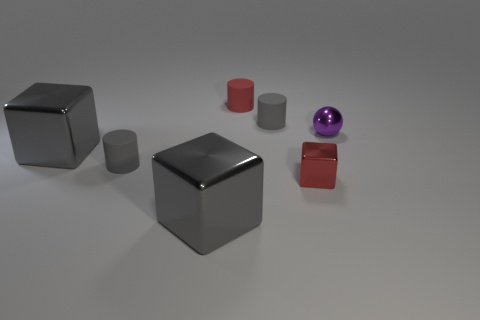Add 2 gray metallic things. How many objects exist? 9 Subtract all balls. How many objects are left? 6 Add 7 purple metal spheres. How many purple metal spheres are left? 8 Add 1 large gray objects. How many large gray objects exist? 3 Subtract 1 purple spheres. How many objects are left? 6 Subtract all large metallic blocks. Subtract all large shiny blocks. How many objects are left? 3 